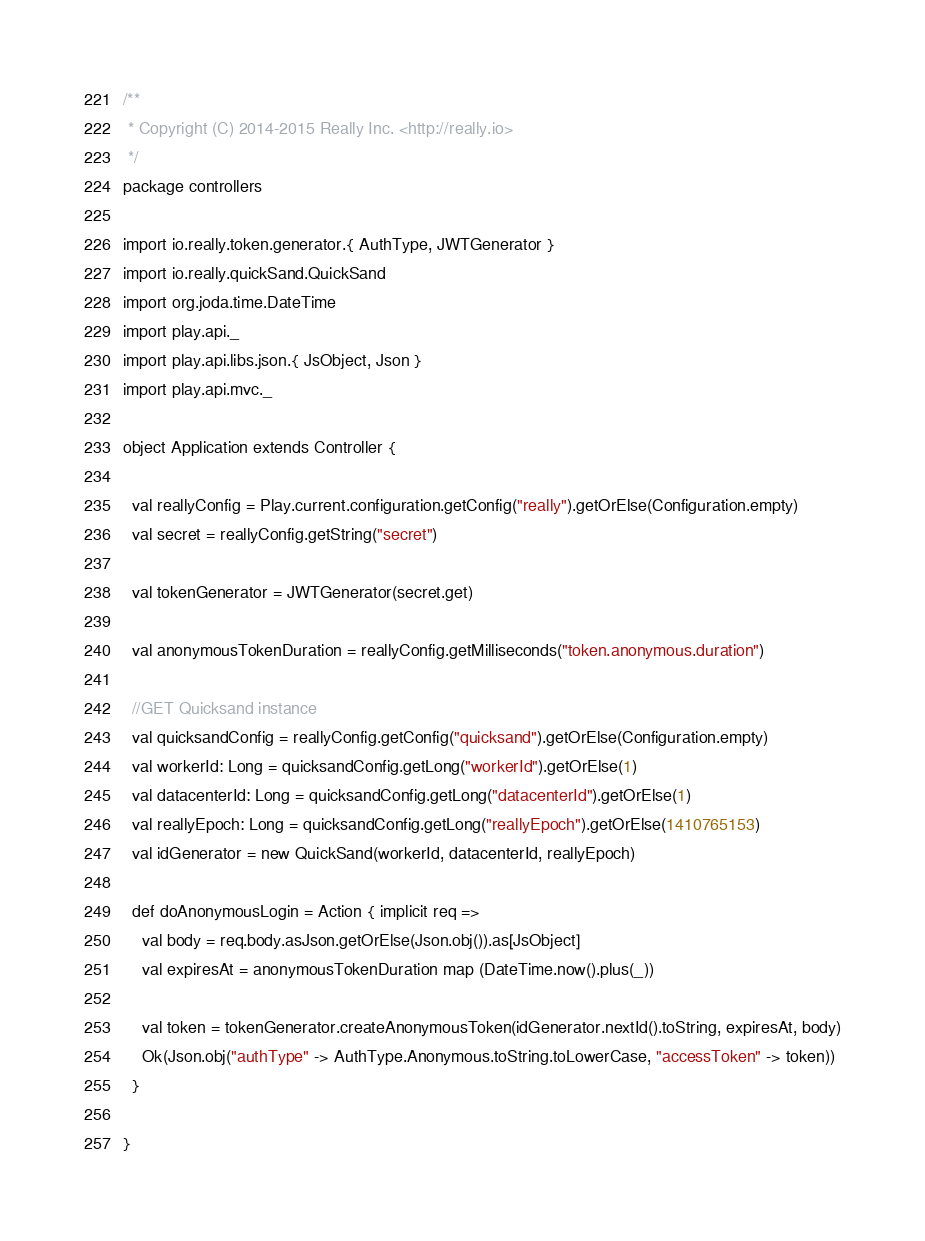<code> <loc_0><loc_0><loc_500><loc_500><_Scala_>/**
 * Copyright (C) 2014-2015 Really Inc. <http://really.io>
 */
package controllers

import io.really.token.generator.{ AuthType, JWTGenerator }
import io.really.quickSand.QuickSand
import org.joda.time.DateTime
import play.api._
import play.api.libs.json.{ JsObject, Json }
import play.api.mvc._

object Application extends Controller {

  val reallyConfig = Play.current.configuration.getConfig("really").getOrElse(Configuration.empty)
  val secret = reallyConfig.getString("secret")

  val tokenGenerator = JWTGenerator(secret.get)

  val anonymousTokenDuration = reallyConfig.getMilliseconds("token.anonymous.duration")

  //GET Quicksand instance
  val quicksandConfig = reallyConfig.getConfig("quicksand").getOrElse(Configuration.empty)
  val workerId: Long = quicksandConfig.getLong("workerId").getOrElse(1)
  val datacenterId: Long = quicksandConfig.getLong("datacenterId").getOrElse(1)
  val reallyEpoch: Long = quicksandConfig.getLong("reallyEpoch").getOrElse(1410765153)
  val idGenerator = new QuickSand(workerId, datacenterId, reallyEpoch)

  def doAnonymousLogin = Action { implicit req =>
    val body = req.body.asJson.getOrElse(Json.obj()).as[JsObject]
    val expiresAt = anonymousTokenDuration map (DateTime.now().plus(_))

    val token = tokenGenerator.createAnonymousToken(idGenerator.nextId().toString, expiresAt, body)
    Ok(Json.obj("authType" -> AuthType.Anonymous.toString.toLowerCase, "accessToken" -> token))
  }

}</code> 